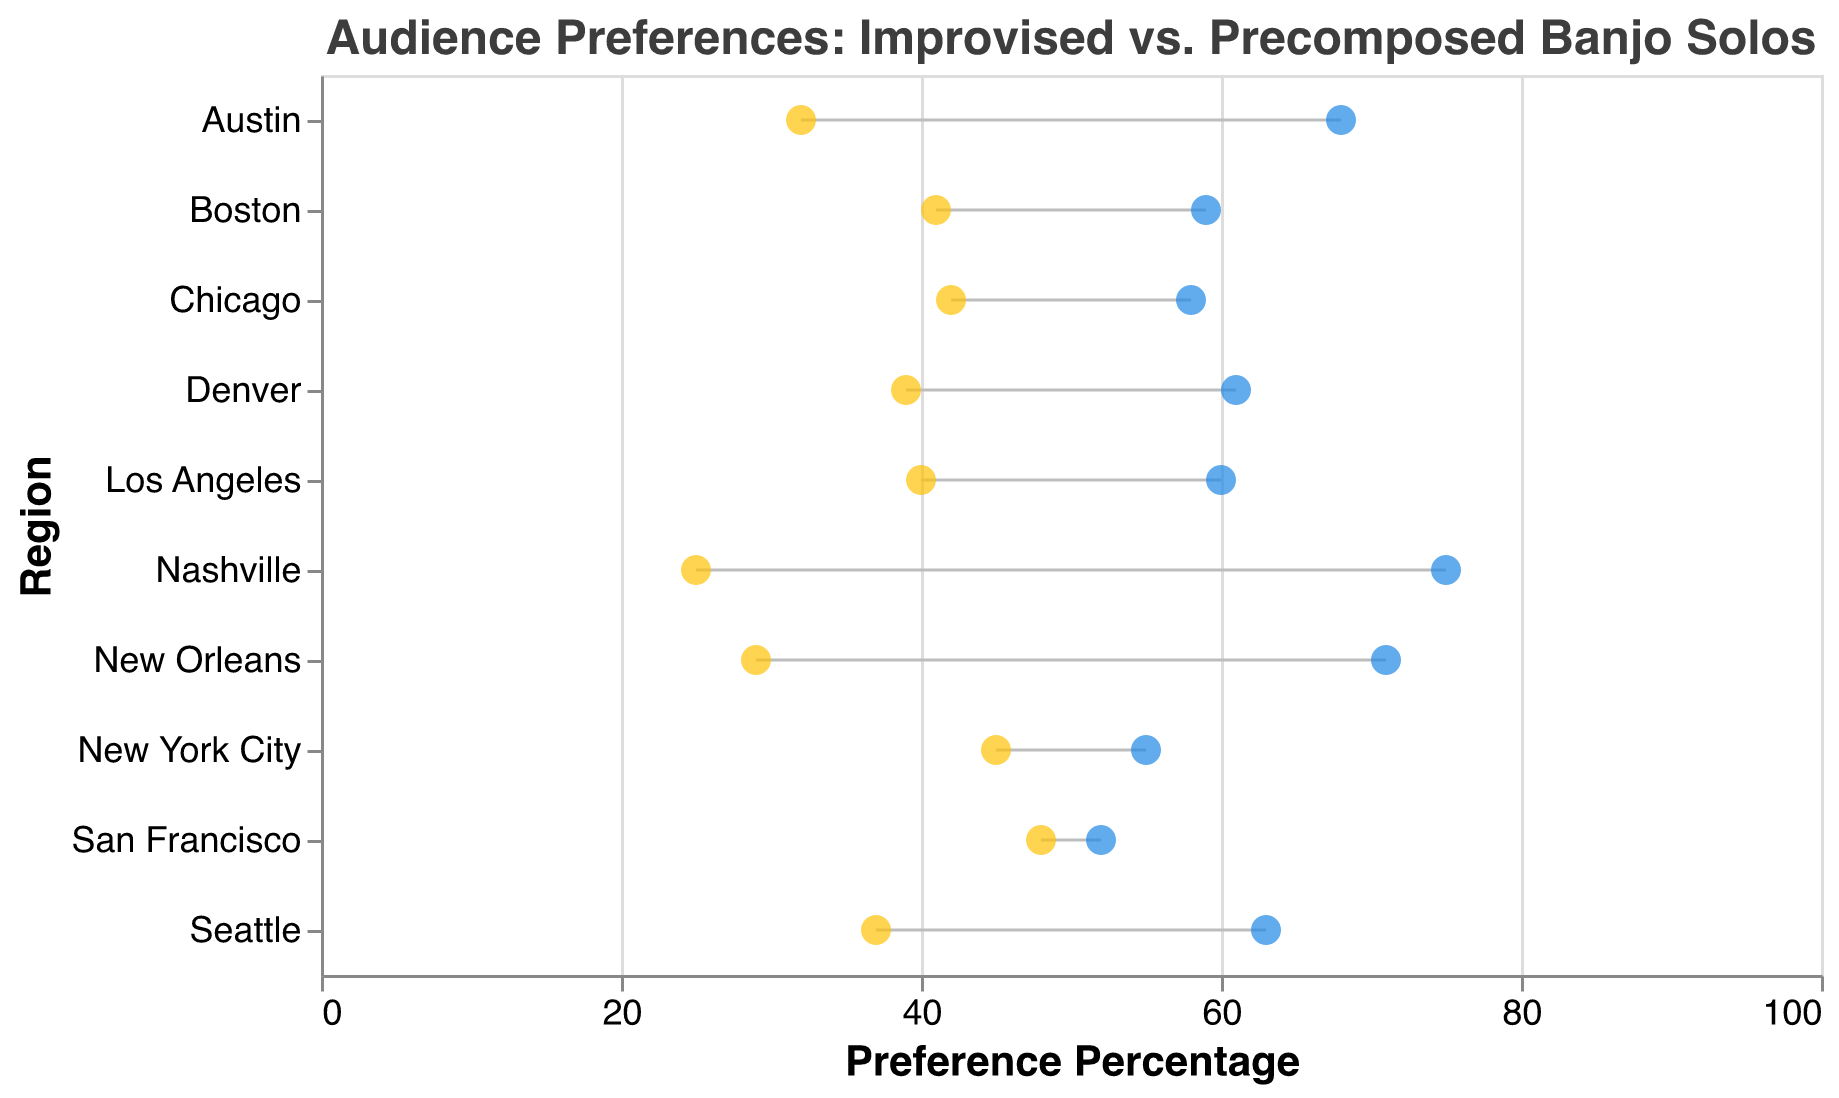What's the title of the figure? The title of the figure is usually at the top and provides a brief description of the data visualization. In this case, the title is "Audience Preferences: Improvised vs. Precomposed Banjo Solos."
Answer: Audience Preferences: Improvised vs. Precomposed Banjo Solos Which region has the highest preference for improvised solos? By looking at the percentage values along the x-axis, the region with the highest value is indicated. Here, Nashville has the highest preference for improvised solos with 75%.
Answer: Nashville What is the preference percentage for precomposed solos in New York City? To find this, look at the data point corresponding to New York City and the relevant percentage value on the x-axis. For New York City, this is 45%.
Answer: 45% What is the difference in preference percentage between improvised and precomposed solos in Austin? The difference can be calculated by subtracting the precomposed percentage from the improvised percentage. For Austin, it's 68% - 32%.
Answer: 36% Which region shows the smallest difference in preference between improvised and precomposed solos? By checking the difference between the two preference percentages for each region, the smallest difference is found for San Francisco, where the improvised solos preference is 52% and precomposed is 48%. The difference is 4%.
Answer: San Francisco How many regions prefer improvised solos more than precomposed solos? Examine the data points for each region and count where the improvised percentage is higher than the precomposed percentage. All regions show a higher preference for improvised solos. Thus, there are 10 such regions.
Answer: 10 Which two regions have the closest preferences for precomposed solos? To find this, compare the percentages for all regions. San Francisco and New York City show closely matching preferences for precomposed solos, with values of 48% and 45%, respectively.
Answer: San Francisco and New York City What’s the average preference percentage for improvised solos across all regions? Sum all the improvised solos preference percentages and divide by the number of regions (10). The values are 75, 68, 55, 60, 58, 52, 63, 59, 71, and 61, summing to 622. Therefore, the average is 622/10.
Answer: 62.2% Which region in the figure reflects a more balanced audience preference between the two types of solos? A balanced preference means the percentages for both types of solos are very close. San Francisco has the closest balance with 52% for improvised and 48% for precomposed solos.
Answer: San Francisco What is the median preference percentage for precomposed banjo solos across all regions? To determine this, write down the precomposed solo percentages in ascending order: 25, 29, 32, 37, 39, 40, 41, 42, 45, 48. The median is the average of the 5th and 6th values in this sorted list, which are 39 and 40. Thus, (39+40)/2.
Answer: 39.5% 